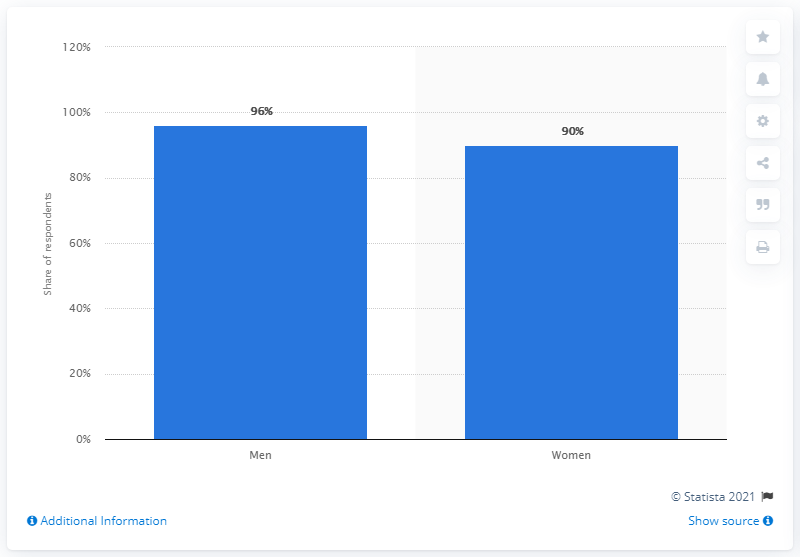Specify some key components in this picture. In 2020, it was reported that approximately 96% of Spanish men had masturbated. 